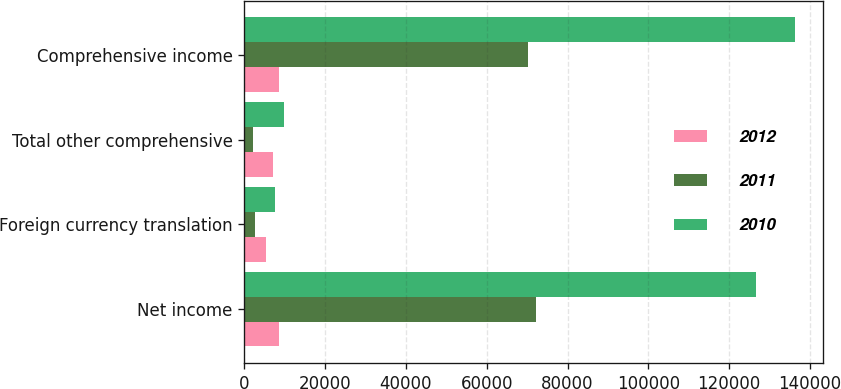<chart> <loc_0><loc_0><loc_500><loc_500><stacked_bar_chart><ecel><fcel>Net income<fcel>Foreign currency translation<fcel>Total other comprehensive<fcel>Comprehensive income<nl><fcel>2012<fcel>8726.5<fcel>5337<fcel>7003<fcel>8726.5<nl><fcel>2011<fcel>72229<fcel>2731<fcel>2103<fcel>70126<nl><fcel>2010<fcel>126538<fcel>7667<fcel>9786<fcel>136324<nl></chart> 